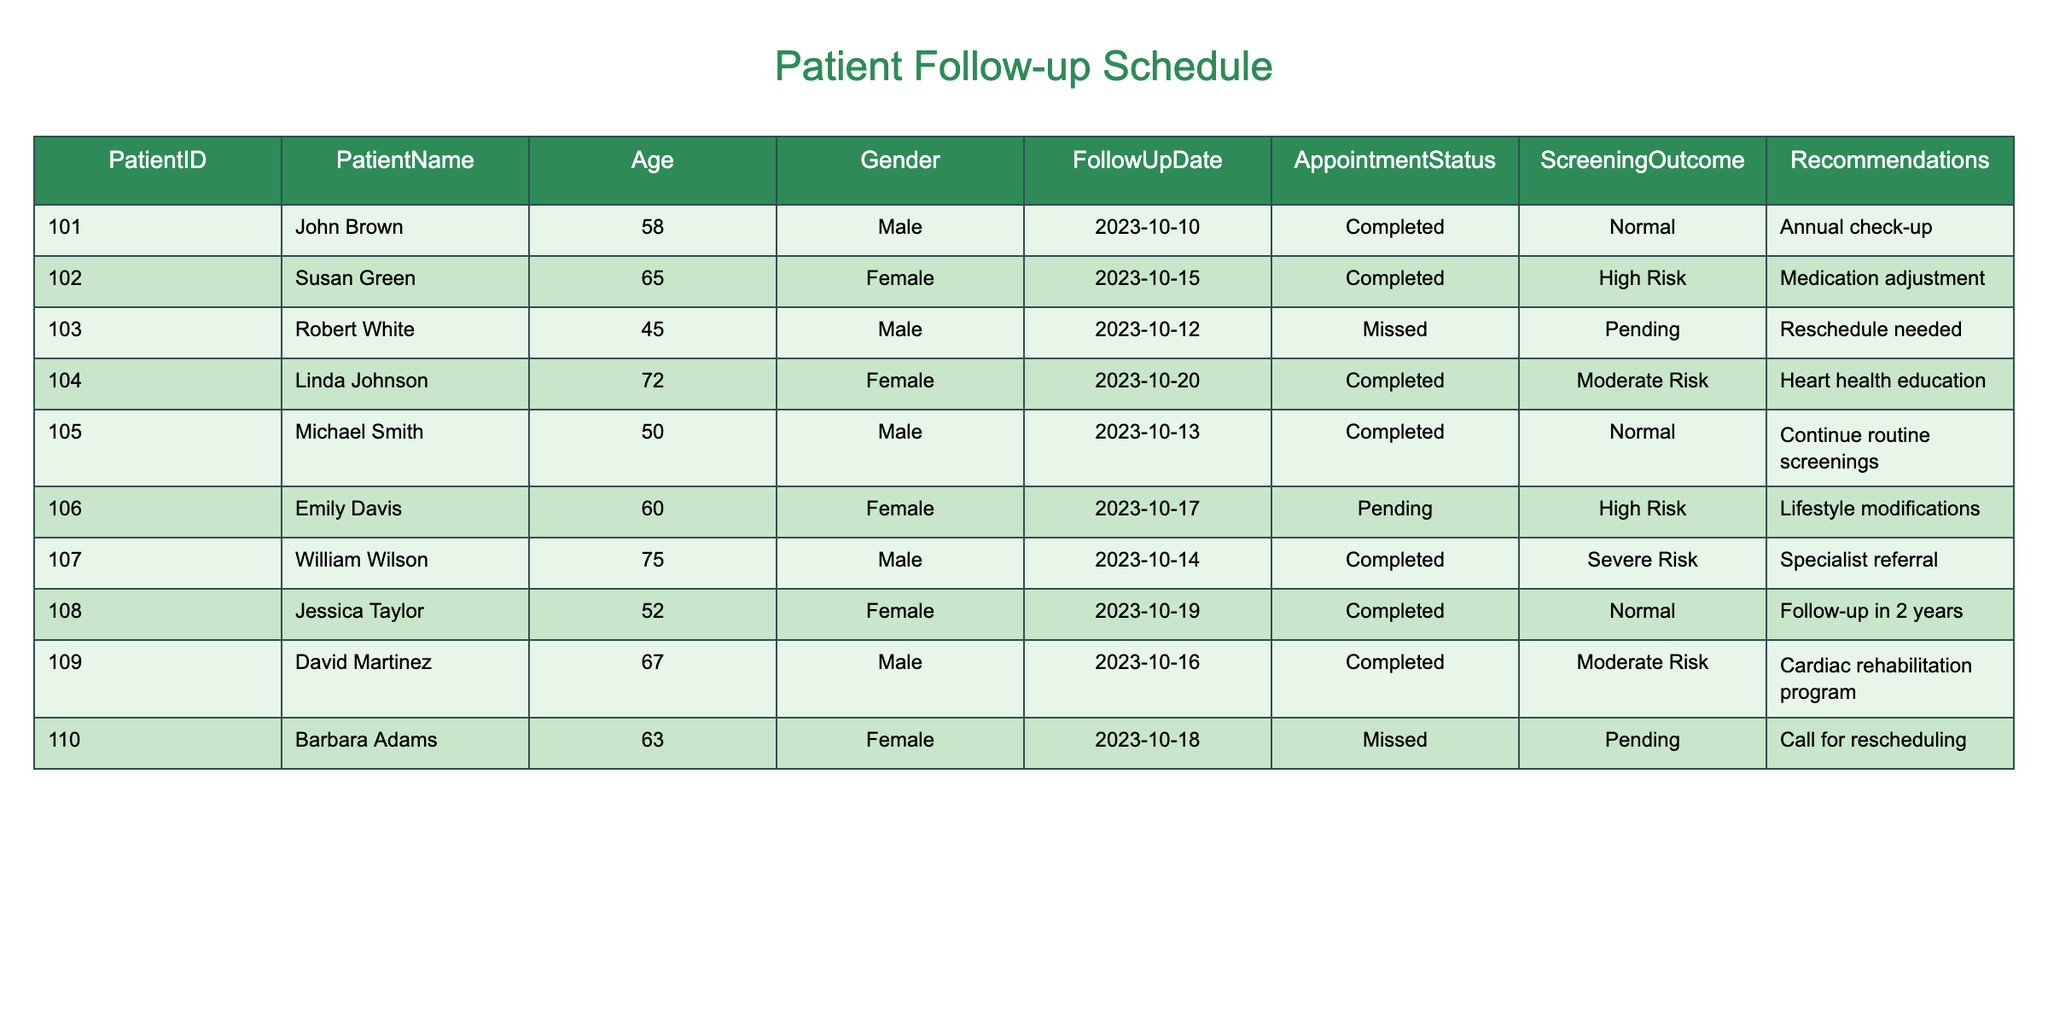What is the follow-up date for John Brown? Referring to the table, John Brown has a follow-up date listed under the FollowUpDate column as 2023-10-10.
Answer: 2023-10-10 How many patients have a "High Risk" screening outcome? By checking the ScreeningOutcome column, both Susan Green and Emily Davis are identified as having a "High Risk" outcome, making a total of 2 patients.
Answer: 2 Did any patients miss their follow-up appointments? Looking at the AppointmentStatus column, both Robert White and Barbara Adams are marked as "Missed", confirming that there were patients who missed their appointments.
Answer: Yes What recommendation was given to William Wilson? In the Recommendations column, it shows that William Wilson was referred to a specialist, which is a crucial recommendation given his scoring.
Answer: Specialist referral What is the average age of patients with a "Moderate Risk" outcome? From the ScreeningOutcome column, we identify David Martinez (67) and Linda Johnson (72) as "Moderate Risk". Their age sum is 67 + 72 = 139, and there are 2 patients, so the average age is 139 / 2 = 69.5.
Answer: 69.5 Which patient has the earliest follow-up appointment? Analyzing the FollowUpDate column, John Brown's appointment on 2023-10-10 is the earliest compared to others.
Answer: John Brown How many patients were categorized as "Normal"? Scanning the ScreeningOutcome, John Brown, Michael Smith, and Jessica Taylor show a "Normal" screening result, totaling 3 patients.
Answer: 3 What is the follow-up recommendation for patients who missed their appointments? Robert White needs to reschedule, and Barbara Adams is advised to call for rescheduling per the Recommendations column.
Answer: Reschedule needed and Call for rescheduling What percentage of patients are at "Severe Risk"? There is 1 patient (William Wilson) classified as "Severe Risk" out of a total of 10 patients. Thus, the percentage is (1/10) * 100 = 10%.
Answer: 10% 